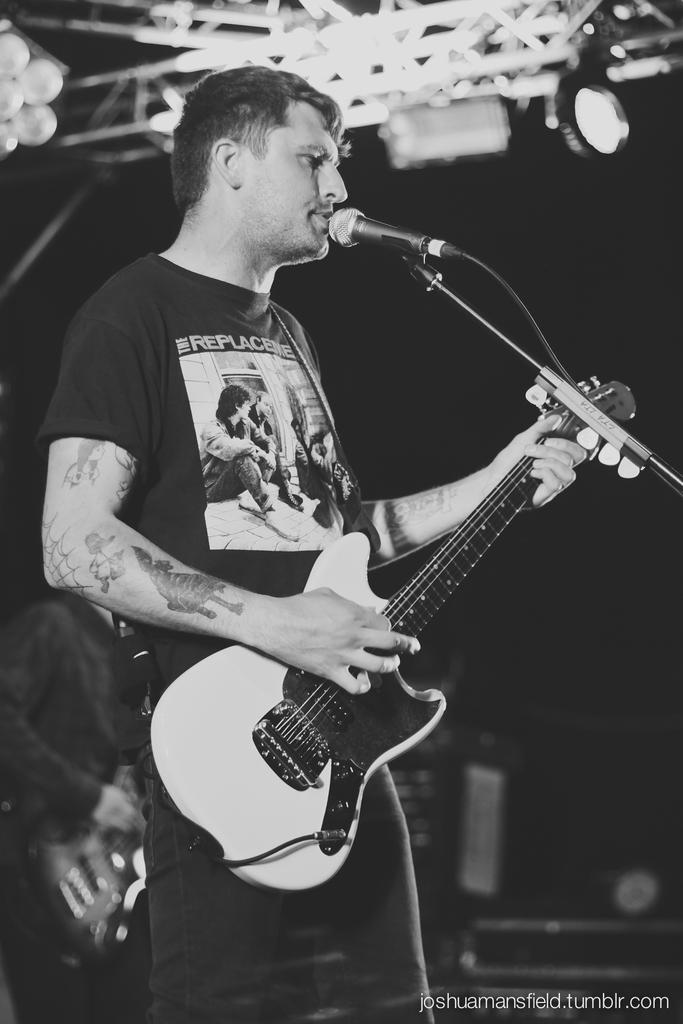What is the person in the image doing? The person is standing in front of a mic and holding a guitar. Can you describe the other person in the image? There is another person in the background holding a guitar. What type of knife is the person using to play the guitar in the image? There is no knife present in the image; the person is playing the guitar with their hands. 